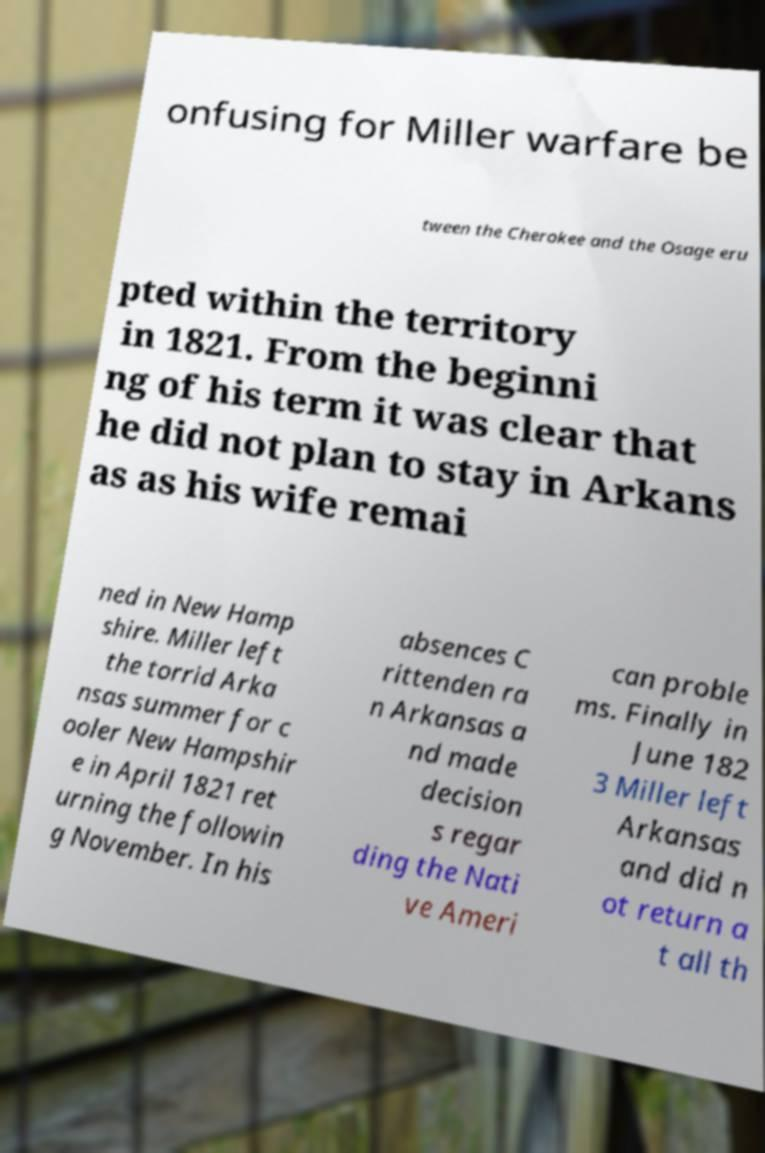What messages or text are displayed in this image? I need them in a readable, typed format. onfusing for Miller warfare be tween the Cherokee and the Osage eru pted within the territory in 1821. From the beginni ng of his term it was clear that he did not plan to stay in Arkans as as his wife remai ned in New Hamp shire. Miller left the torrid Arka nsas summer for c ooler New Hampshir e in April 1821 ret urning the followin g November. In his absences C rittenden ra n Arkansas a nd made decision s regar ding the Nati ve Ameri can proble ms. Finally in June 182 3 Miller left Arkansas and did n ot return a t all th 